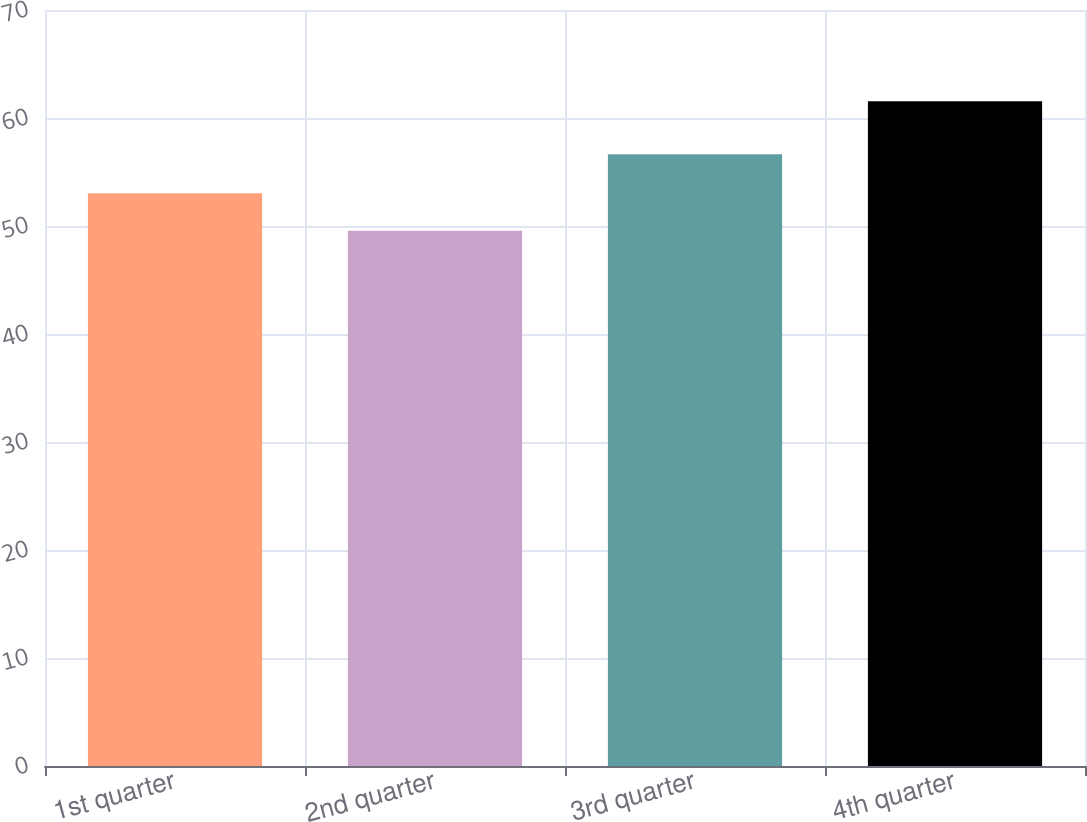<chart> <loc_0><loc_0><loc_500><loc_500><bar_chart><fcel>1st quarter<fcel>2nd quarter<fcel>3rd quarter<fcel>4th quarter<nl><fcel>53.04<fcel>49.56<fcel>56.64<fcel>61.55<nl></chart> 